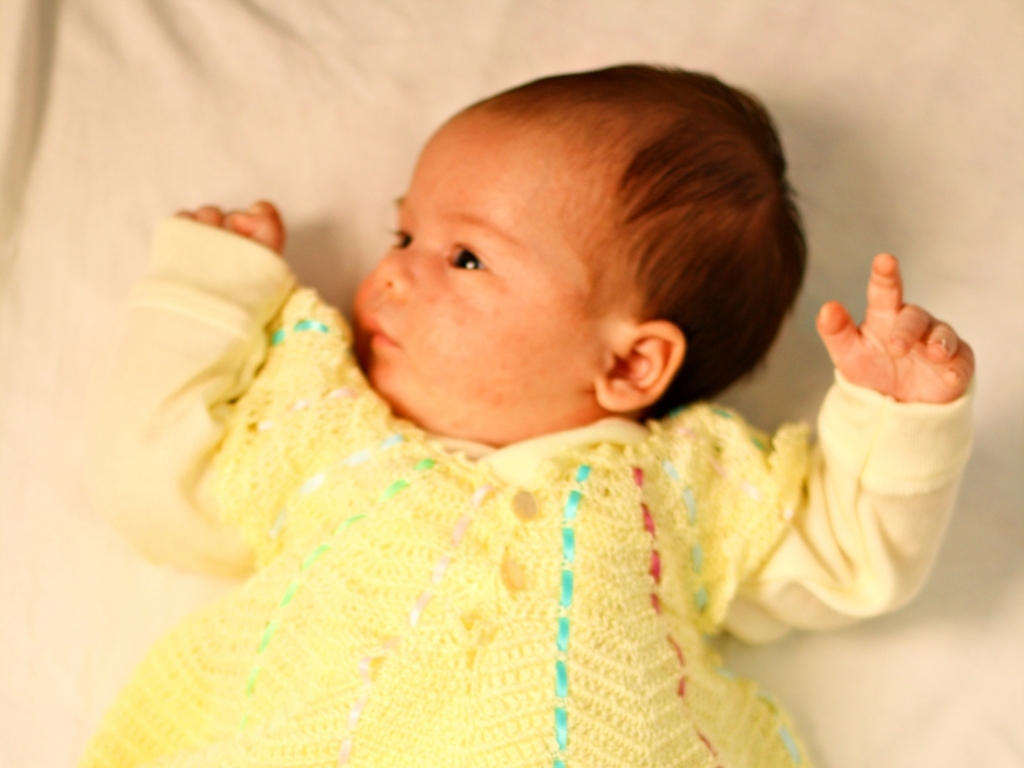What feeling does this image evoke? The image instills a sense of innocence and tenderness, accentuated by the soft focus and the gentle expression of the baby. The warm hues and delicate garment contribute to a feeling of comfort and care. 